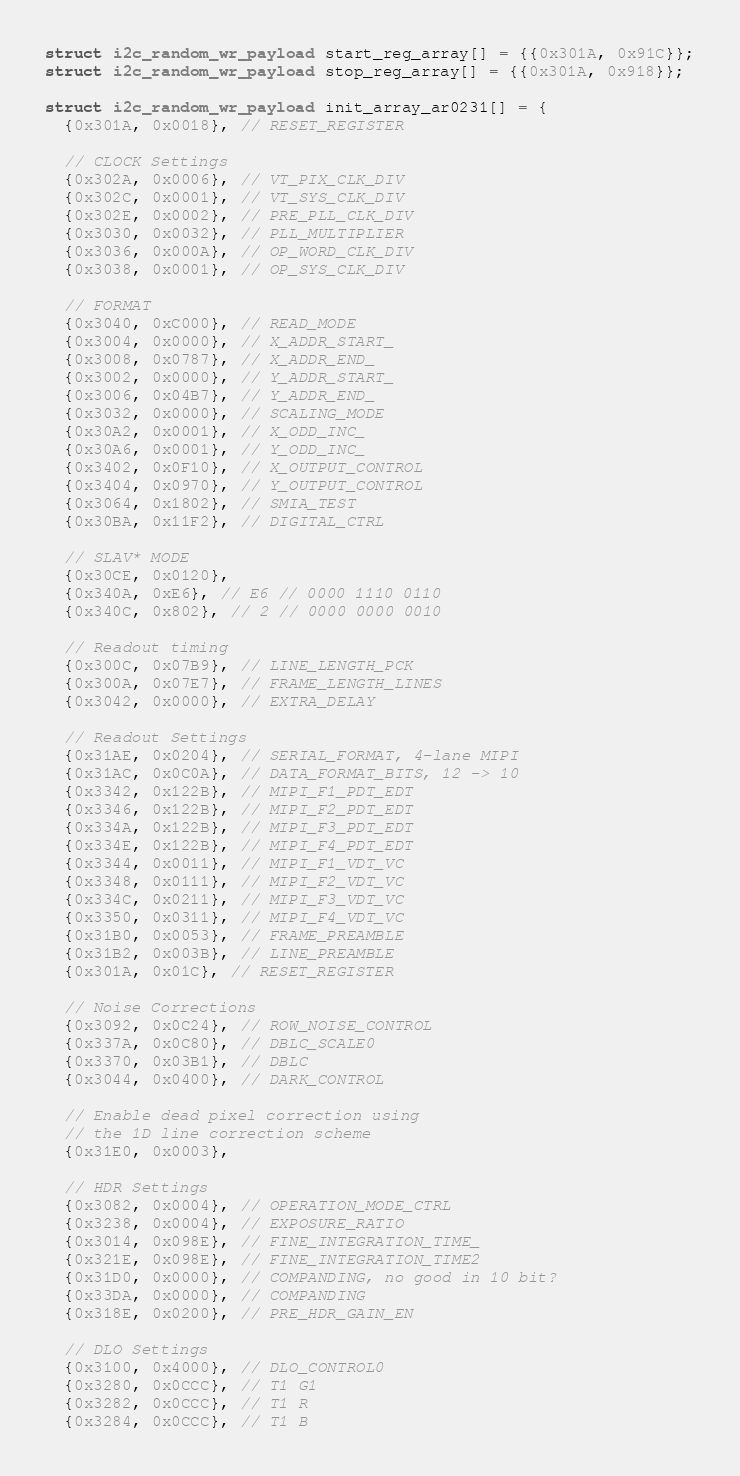<code> <loc_0><loc_0><loc_500><loc_500><_C_>struct i2c_random_wr_payload start_reg_array[] = {{0x301A, 0x91C}};
struct i2c_random_wr_payload stop_reg_array[] = {{0x301A, 0x918}};

struct i2c_random_wr_payload init_array_ar0231[] = {
  {0x301A, 0x0018}, // RESET_REGISTER

  // CLOCK Settings
  {0x302A, 0x0006}, // VT_PIX_CLK_DIV
  {0x302C, 0x0001}, // VT_SYS_CLK_DIV
  {0x302E, 0x0002}, // PRE_PLL_CLK_DIV
  {0x3030, 0x0032}, // PLL_MULTIPLIER
  {0x3036, 0x000A}, // OP_WORD_CLK_DIV
  {0x3038, 0x0001}, // OP_SYS_CLK_DIV

  // FORMAT
  {0x3040, 0xC000}, // READ_MODE
  {0x3004, 0x0000}, // X_ADDR_START_
  {0x3008, 0x0787}, // X_ADDR_END_
  {0x3002, 0x0000}, // Y_ADDR_START_
  {0x3006, 0x04B7}, // Y_ADDR_END_
  {0x3032, 0x0000}, // SCALING_MODE
  {0x30A2, 0x0001}, // X_ODD_INC_
  {0x30A6, 0x0001}, // Y_ODD_INC_
  {0x3402, 0x0F10}, // X_OUTPUT_CONTROL
  {0x3404, 0x0970}, // Y_OUTPUT_CONTROL
  {0x3064, 0x1802}, // SMIA_TEST
  {0x30BA, 0x11F2}, // DIGITAL_CTRL

  // SLAV* MODE
  {0x30CE, 0x0120},
  {0x340A, 0xE6}, // E6 // 0000 1110 0110
  {0x340C, 0x802}, // 2 // 0000 0000 0010

  // Readout timing
  {0x300C, 0x07B9}, // LINE_LENGTH_PCK
  {0x300A, 0x07E7}, // FRAME_LENGTH_LINES
  {0x3042, 0x0000}, // EXTRA_DELAY

  // Readout Settings
  {0x31AE, 0x0204}, // SERIAL_FORMAT, 4-lane MIPI
  {0x31AC, 0x0C0A}, // DATA_FORMAT_BITS, 12 -> 10
  {0x3342, 0x122B}, // MIPI_F1_PDT_EDT
  {0x3346, 0x122B}, // MIPI_F2_PDT_EDT
  {0x334A, 0x122B}, // MIPI_F3_PDT_EDT
  {0x334E, 0x122B}, // MIPI_F4_PDT_EDT
  {0x3344, 0x0011}, // MIPI_F1_VDT_VC
  {0x3348, 0x0111}, // MIPI_F2_VDT_VC
  {0x334C, 0x0211}, // MIPI_F3_VDT_VC
  {0x3350, 0x0311}, // MIPI_F4_VDT_VC
  {0x31B0, 0x0053}, // FRAME_PREAMBLE
  {0x31B2, 0x003B}, // LINE_PREAMBLE
  {0x301A, 0x01C}, // RESET_REGISTER

  // Noise Corrections
  {0x3092, 0x0C24}, // ROW_NOISE_CONTROL
  {0x337A, 0x0C80}, // DBLC_SCALE0
  {0x3370, 0x03B1}, // DBLC
  {0x3044, 0x0400}, // DARK_CONTROL

  // Enable dead pixel correction using
  // the 1D line correction scheme
  {0x31E0, 0x0003},

  // HDR Settings
  {0x3082, 0x0004}, // OPERATION_MODE_CTRL
  {0x3238, 0x0004}, // EXPOSURE_RATIO
  {0x3014, 0x098E}, // FINE_INTEGRATION_TIME_
  {0x321E, 0x098E}, // FINE_INTEGRATION_TIME2
  {0x31D0, 0x0000}, // COMPANDING, no good in 10 bit?
  {0x33DA, 0x0000}, // COMPANDING
  {0x318E, 0x0200}, // PRE_HDR_GAIN_EN

  // DLO Settings
  {0x3100, 0x4000}, // DLO_CONTROL0
  {0x3280, 0x0CCC}, // T1 G1
  {0x3282, 0x0CCC}, // T1 R
  {0x3284, 0x0CCC}, // T1 B</code> 